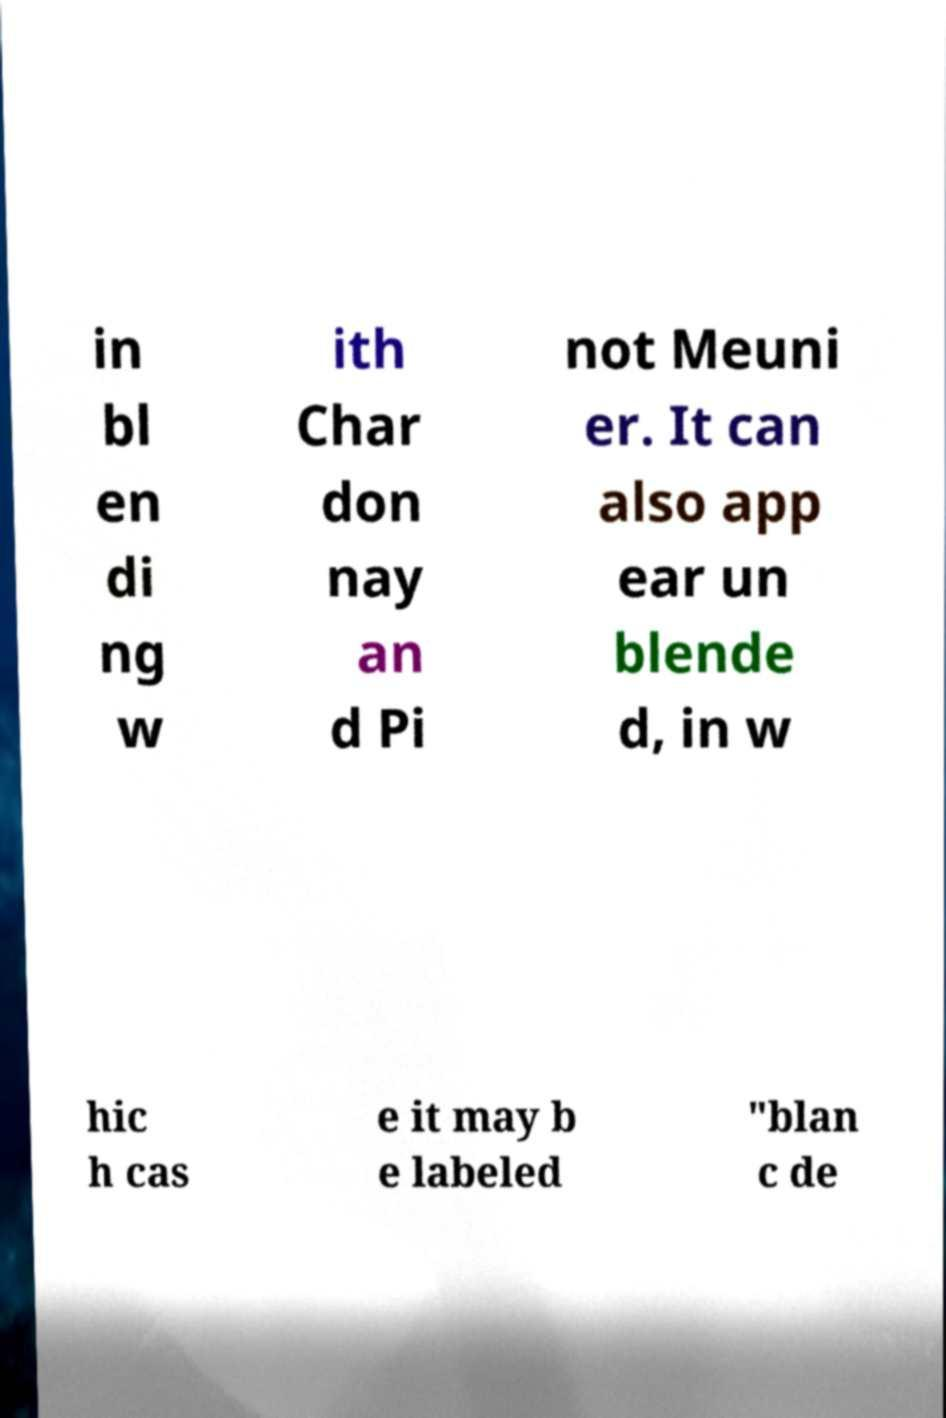Can you read and provide the text displayed in the image?This photo seems to have some interesting text. Can you extract and type it out for me? in bl en di ng w ith Char don nay an d Pi not Meuni er. It can also app ear un blende d, in w hic h cas e it may b e labeled "blan c de 